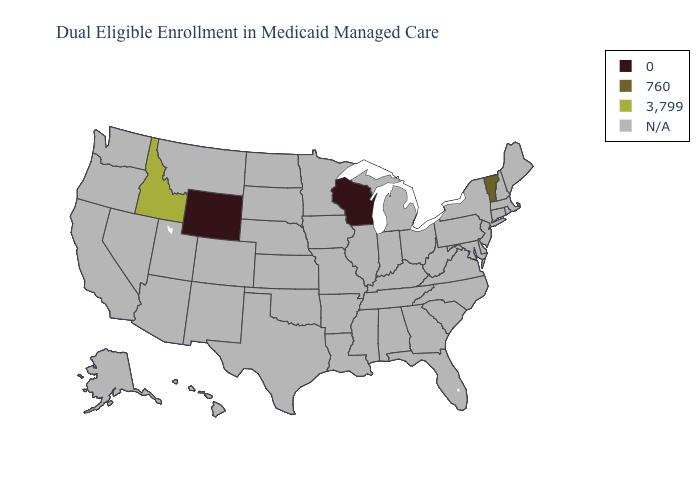What is the value of Idaho?
Quick response, please. 3,799. Which states have the lowest value in the USA?
Keep it brief. Wisconsin, Wyoming. Which states have the lowest value in the USA?
Be succinct. Wisconsin, Wyoming. Does Idaho have the highest value in the USA?
Write a very short answer. Yes. Does Idaho have the highest value in the USA?
Concise answer only. Yes. What is the highest value in the West ?
Give a very brief answer. 3,799. Which states hav the highest value in the MidWest?
Write a very short answer. Wisconsin. What is the lowest value in the USA?
Write a very short answer. 0. Which states have the lowest value in the USA?
Concise answer only. Wisconsin, Wyoming. Which states have the highest value in the USA?
Answer briefly. Idaho. Which states have the highest value in the USA?
Concise answer only. Idaho. Name the states that have a value in the range 3,799?
Keep it brief. Idaho. What is the lowest value in the USA?
Concise answer only. 0. 